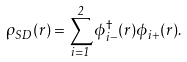Convert formula to latex. <formula><loc_0><loc_0><loc_500><loc_500>\rho _ { S D } ( { r } ) = \sum _ { i = 1 } ^ { 2 } \phi ^ { \dagger } _ { i - } ( { r } ) \phi _ { i + } ( { r } ) .</formula> 